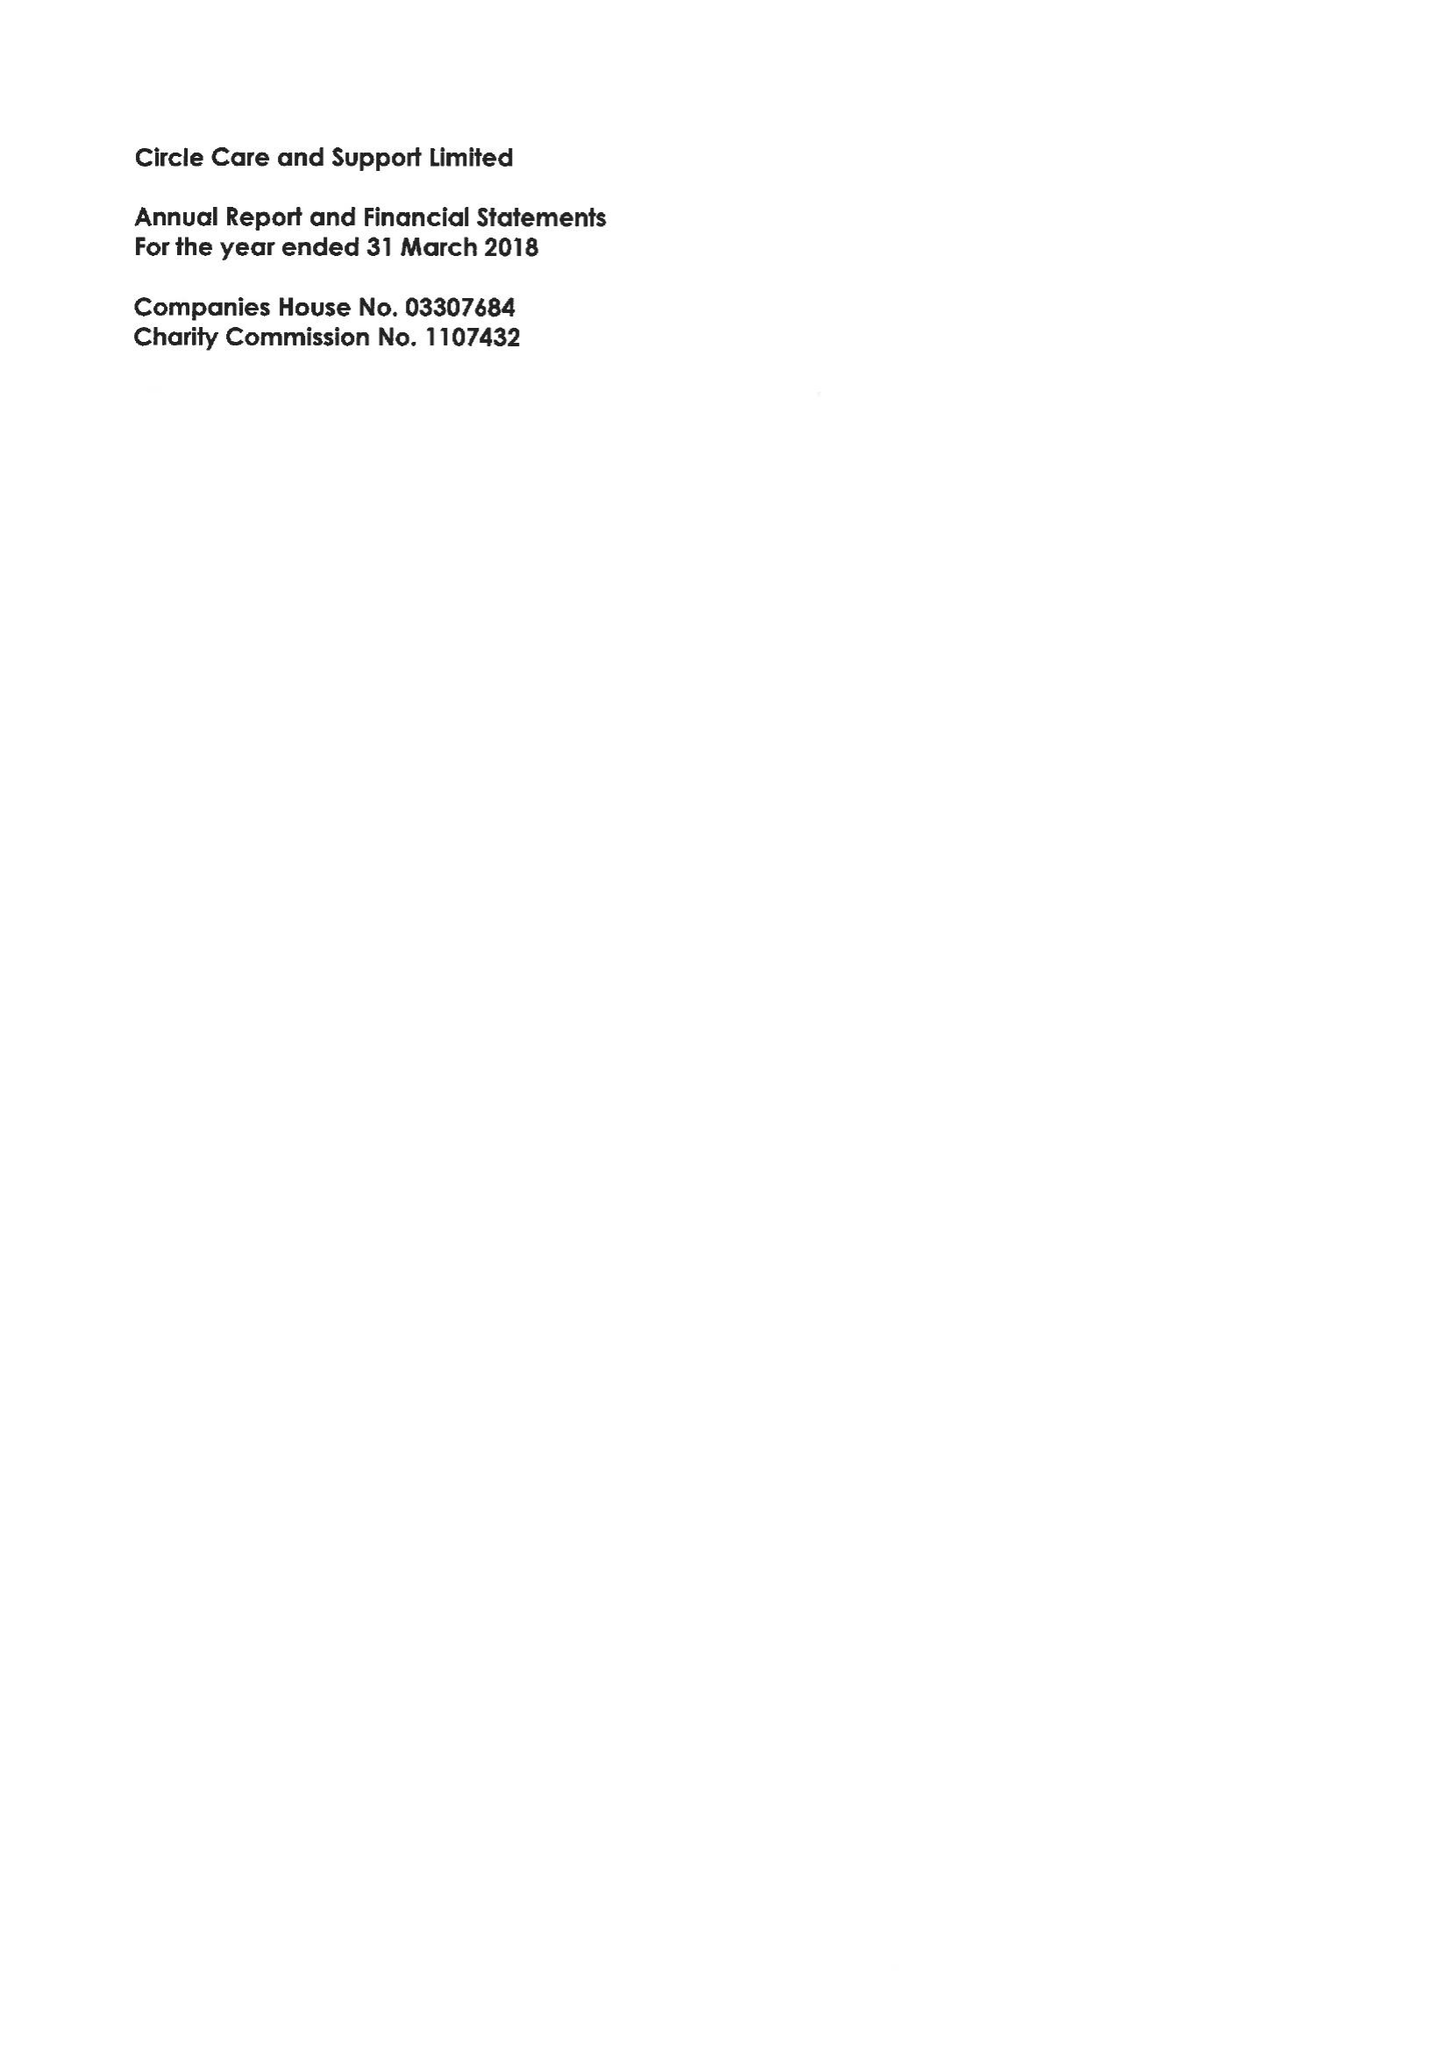What is the value for the address__post_town?
Answer the question using a single word or phrase. LONDON 